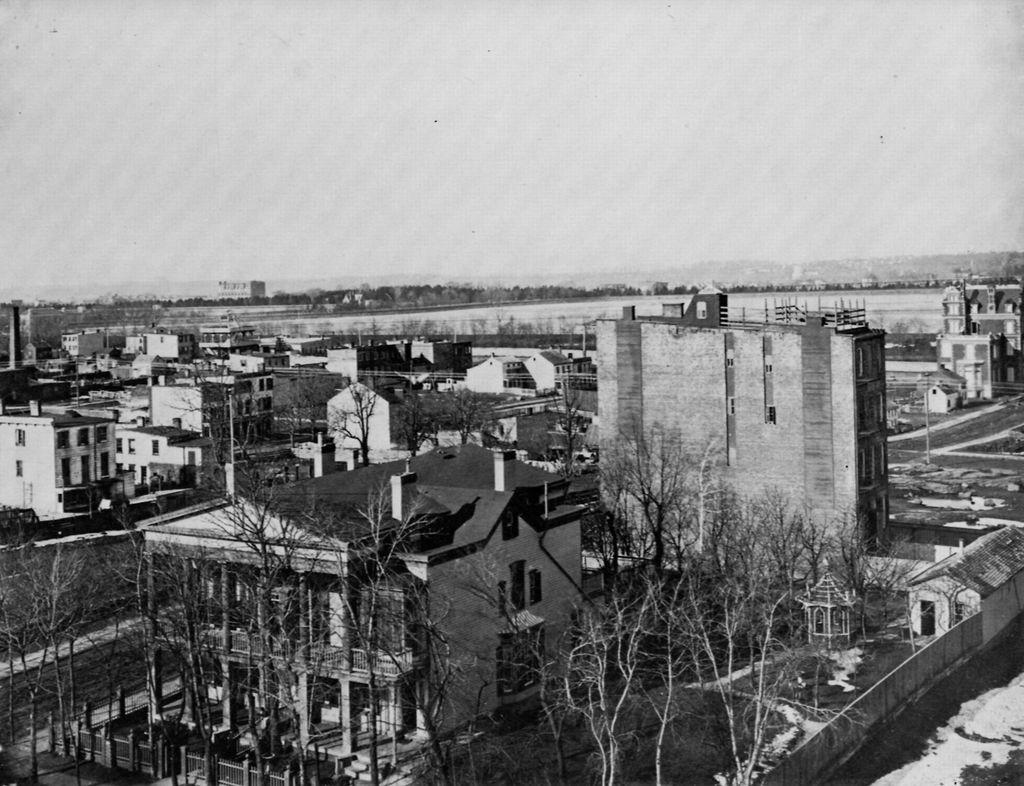What perspective is used in the image? The image shows a top view of a place. What types of structures are visible in the image? There are houses and buildings in the image. What natural elements can be seen in the image? There are trees and plants in the image. How many crackers are visible in the image? There are no crackers present in the image. What word is written on the trees in the image? There is no word written on the trees in the image, as trees do not have the ability to have words written on them. 